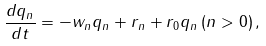Convert formula to latex. <formula><loc_0><loc_0><loc_500><loc_500>\frac { d q _ { n } } { d t } = - w _ { n } q _ { n } + r _ { n } + r _ { 0 } q _ { n } \, ( n > 0 ) \, ,</formula> 